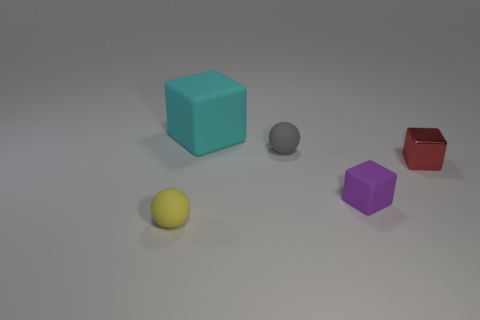Subtract all large cyan blocks. How many blocks are left? 2 Add 4 small purple cubes. How many objects exist? 9 Subtract all purple cubes. How many cubes are left? 2 Subtract 2 spheres. How many spheres are left? 0 Subtract all balls. How many objects are left? 3 Subtract all blue cylinders. How many purple blocks are left? 1 Subtract all big cyan shiny cylinders. Subtract all large cyan rubber cubes. How many objects are left? 4 Add 3 tiny gray rubber objects. How many tiny gray rubber objects are left? 4 Add 5 large cyan objects. How many large cyan objects exist? 6 Subtract 0 cyan balls. How many objects are left? 5 